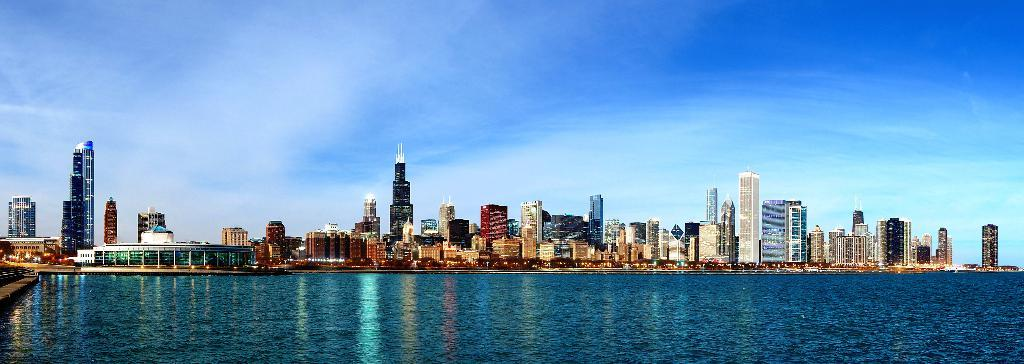What structures are present in the image? There are buildings in the image. What is located in front of the buildings? There is water in front of the buildings. What can be seen in the background of the image? The sky is visible in the background of the image. What direction is the light coming from in the image? There is no specific mention of light in the image, so it is not possible to determine the direction from which the light is coming. 